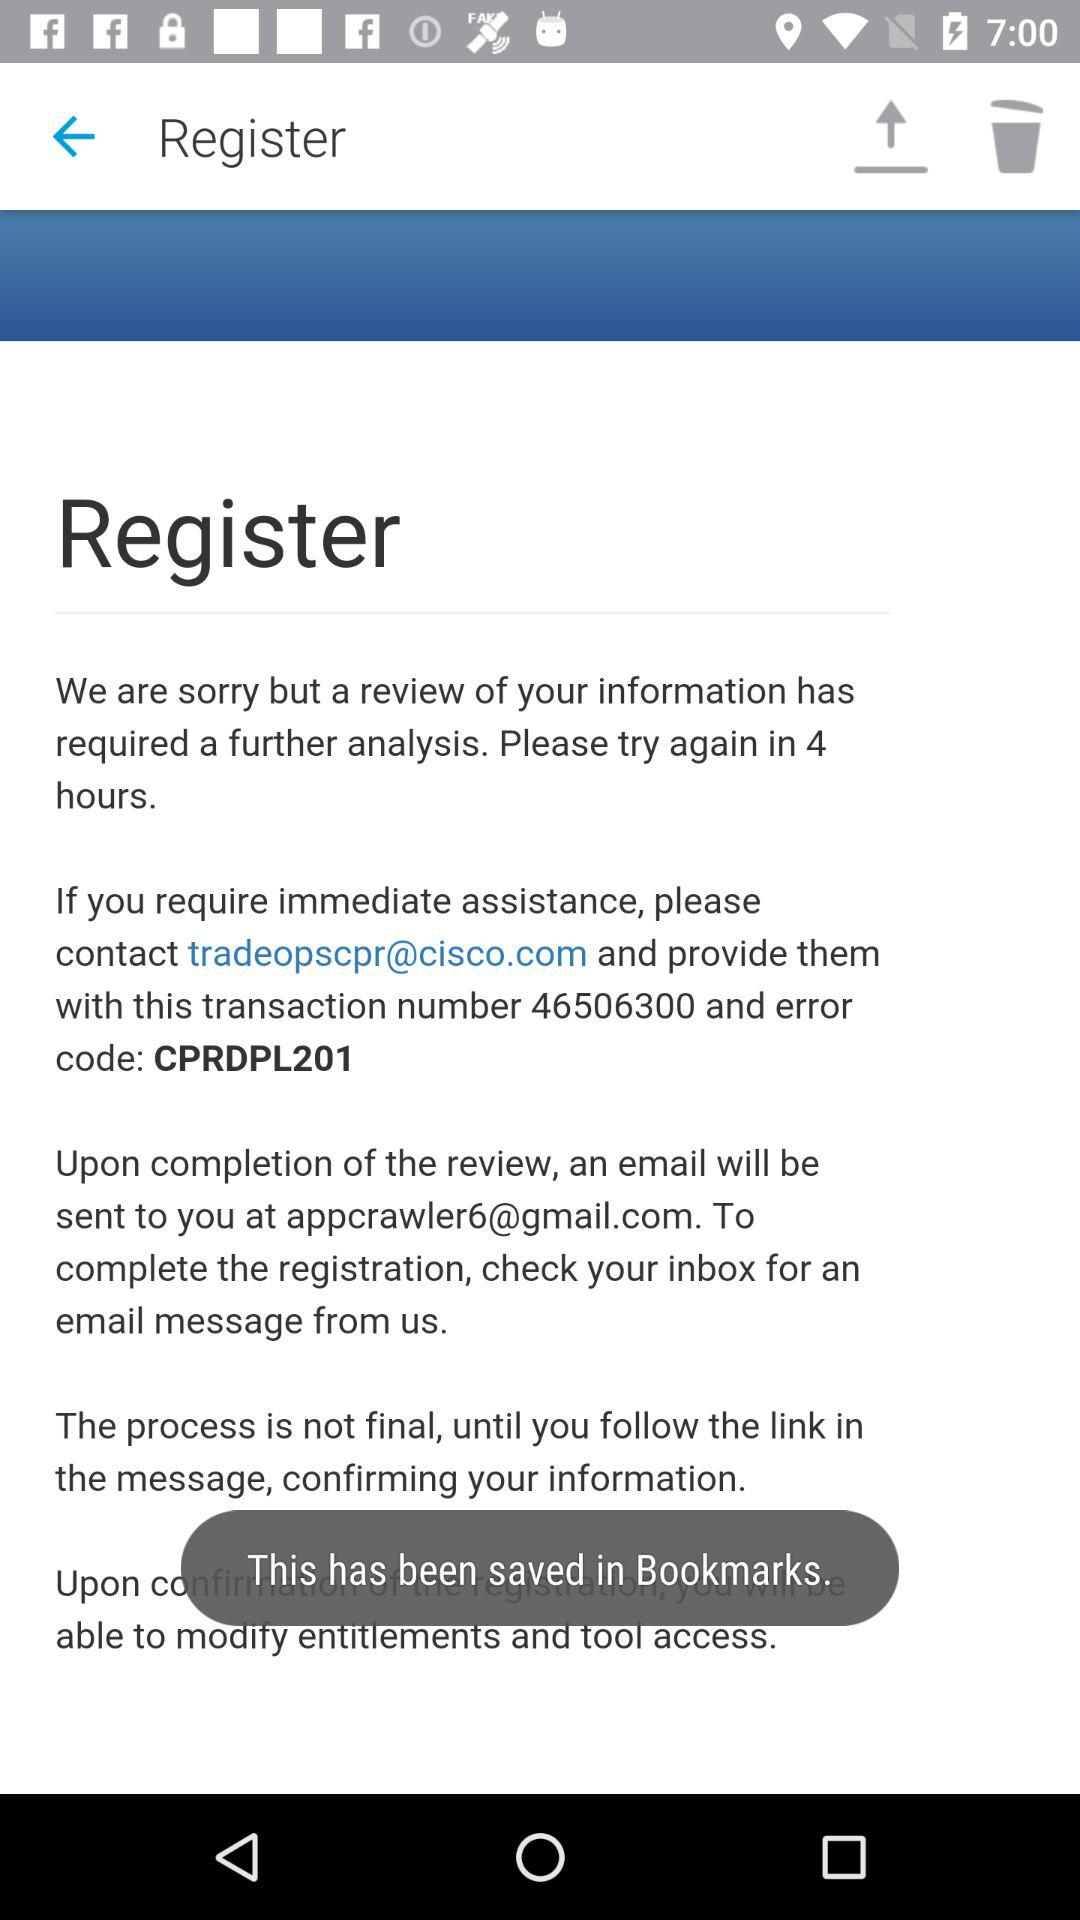What is the email address for immediate assistance? The email address is tradeopscpr@cisco.com. 